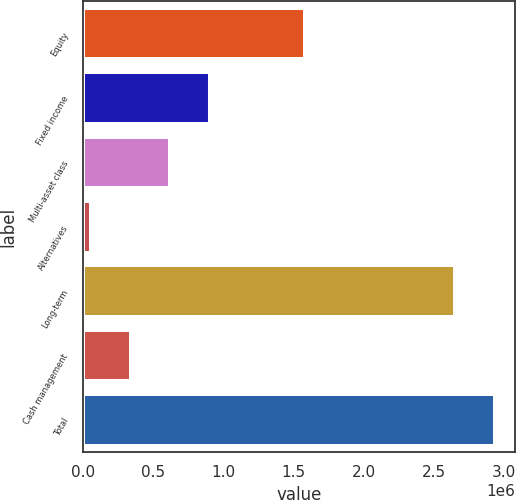Convert chart. <chart><loc_0><loc_0><loc_500><loc_500><bar_chart><fcel>Equity<fcel>Fixed income<fcel>Multi-asset class<fcel>Alternatives<fcel>Long-term<fcel>Cash management<fcel>Total<nl><fcel>1.58353e+06<fcel>899874<fcel>618805<fcel>56668<fcel>2.65193e+06<fcel>337736<fcel>2.933e+06<nl></chart> 